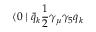<formula> <loc_0><loc_0><loc_500><loc_500>\langle 0 | \bar { q } _ { k } { \frac { 1 } { 2 } } \gamma _ { \mu } \gamma _ { 5 } q _ { k }</formula> 